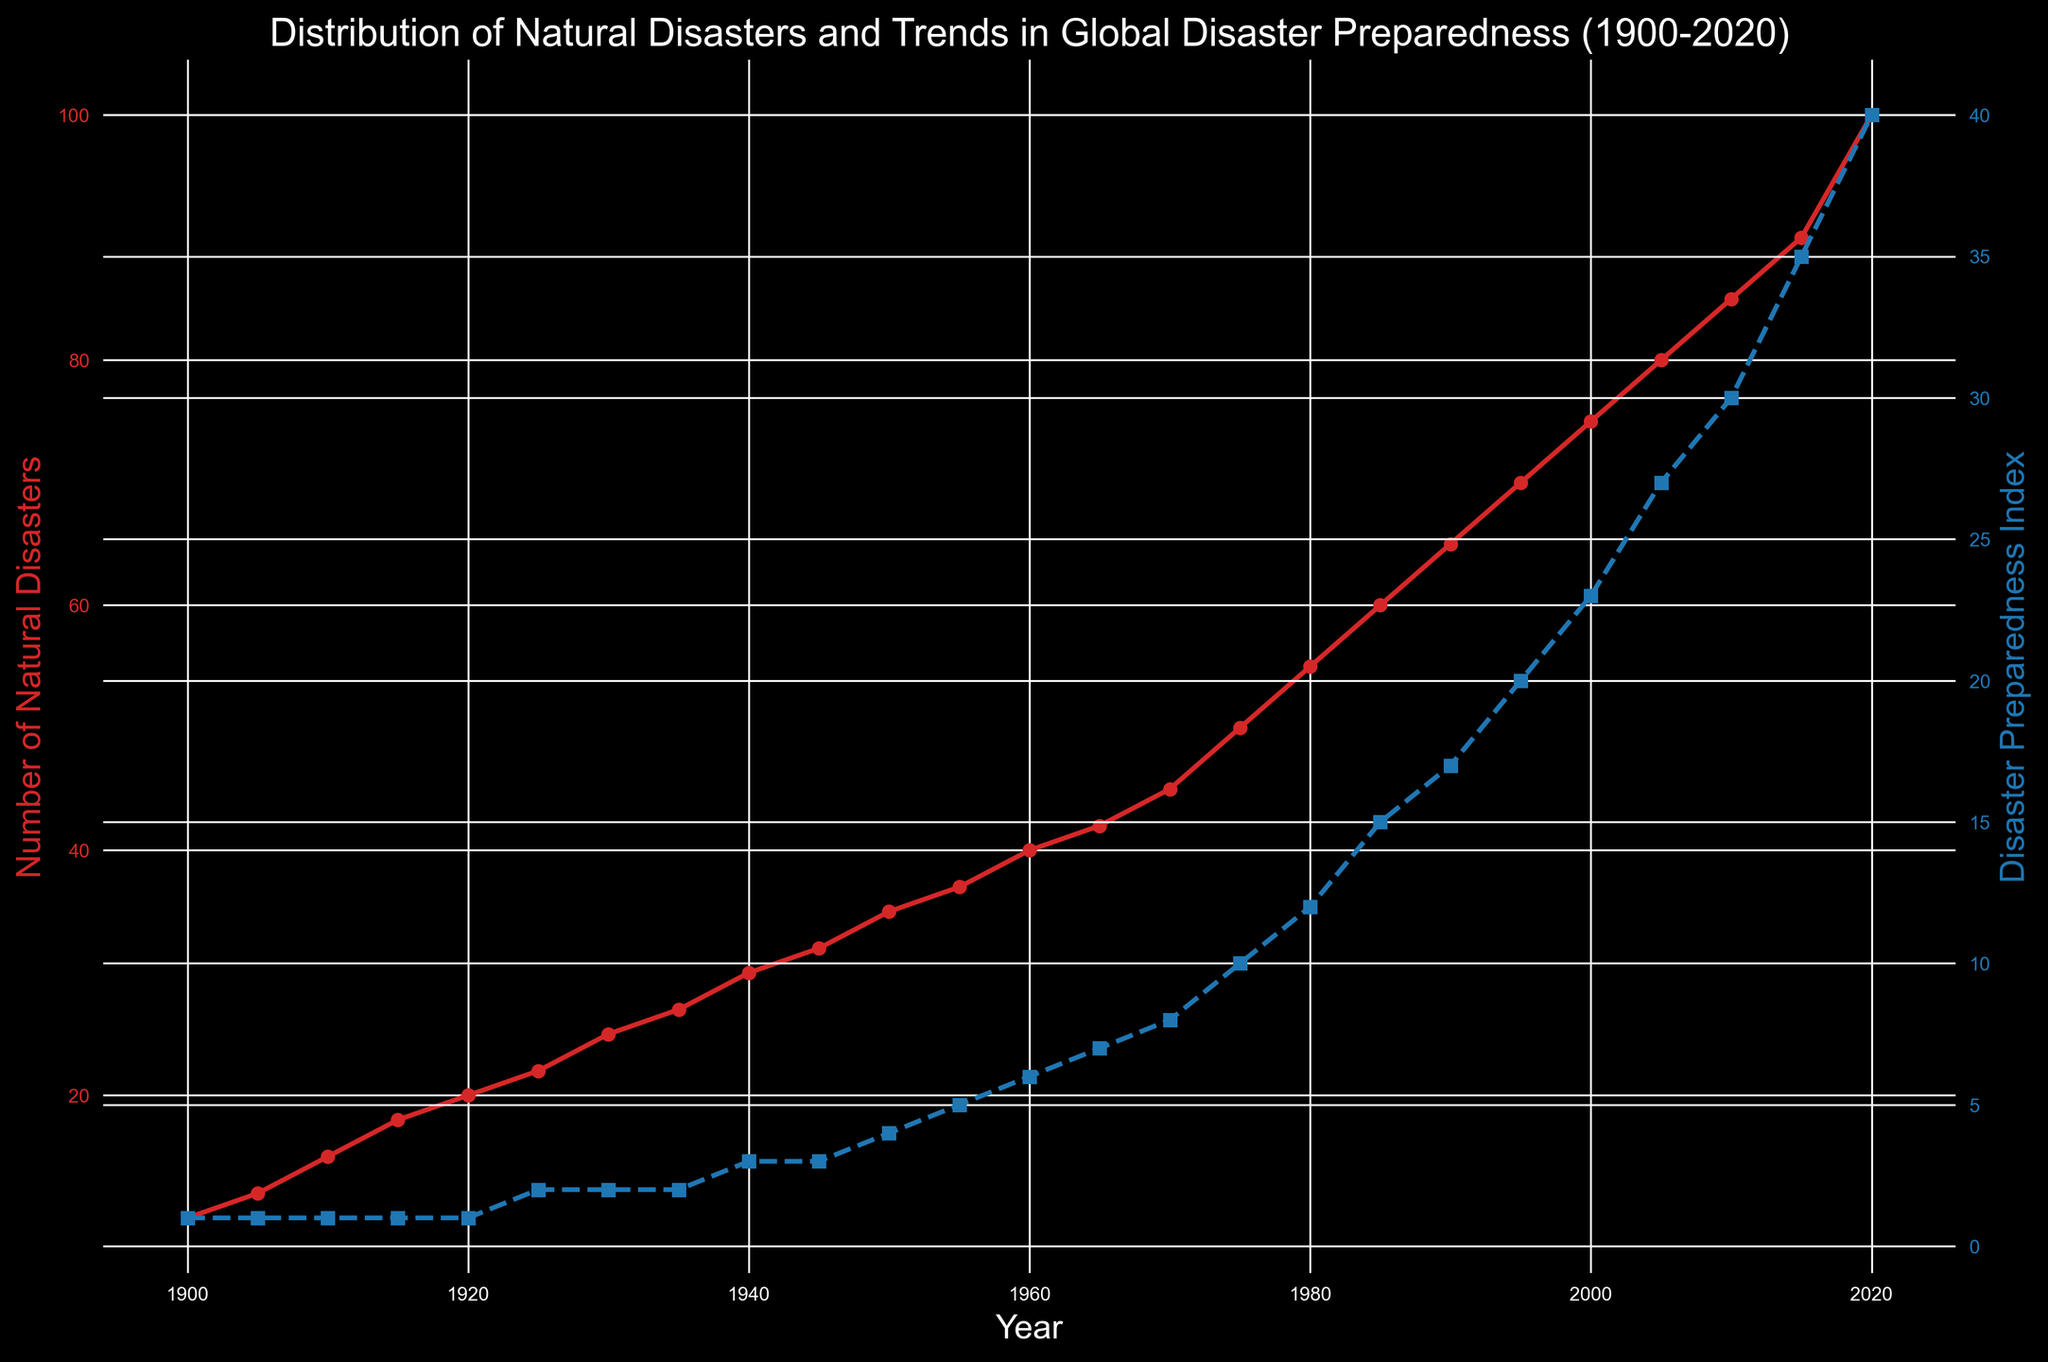What's the general trend of natural disasters from 1900 to 2020? The plot shows an increasing trend of natural disasters over time. Starting from 10 in 1900, the number of natural disasters steadily rises to 100 in 2020.
Answer: Increasing How does the disaster preparedness index change over the years? The disaster preparedness index shows an upward trend throughout the years. Initially at 1 in 1900, it significantly increases to 40 by 2020.
Answer: Increasing Compare the number of natural disasters in 1950 and 2020. In 1950, the number of natural disasters is 35, while in 2020, it is 100. Therefore, the number of natural disasters in 2020 is significantly higher than in 1950.
Answer: Higher in 2020 What is the difference in the disaster preparedness index between 1980 and 2020? The disaster preparedness index in 1980 is 12, and in 2020 it is 40. The difference is calculated as 40 - 12 = 28.
Answer: 28 Around what year does the disaster preparedness index start to show a steep increase? Observing the plot, the disaster preparedness index starts to show a noticeable steep increase around 1975.
Answer: Around 1975 Estimate the average number of natural disasters per decade from 1900 to 1920. Average for 1900 (10), 1905 (12), 1910 (15), 1915 (18), and 1920 (20) can be calculated as: (10 + 12 + 15 + 18 + 20) / 5. This gives: 75 / 5 = 15.
Answer: 15 Compare trends of natural disasters and disaster preparedness index from 1970 to 2000. From 1970 to 2000, natural disasters rise from 45 to 75 (increase by 30), while disaster preparedness index rises from 8 to 23 (increase by 15). Both show upward trends, but natural disasters increase at a faster rate.
Answer: Both upward, natural disasters faster How does the increase in the disaster preparedness index from 1990 to 2020 compare to its increase from 1960 to 1990? From 1990 to 2020, the index rises from 17 to 40 (increase by 23), and from 1960 to 1990, it rises from 6 to 17 (increase by 11). The increase from 1990 to 2020 is greater.
Answer: Greater from 1990 to 2020 What's the correlation between the two variables in the plot? Both natural disasters and the disaster preparedness index show upward trends over time, suggesting a positive correlation between them.
Answer: Positive 